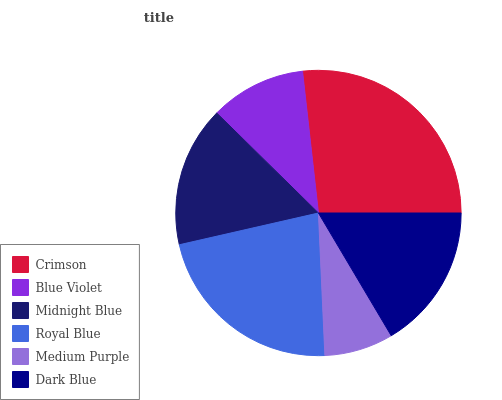Is Medium Purple the minimum?
Answer yes or no. Yes. Is Crimson the maximum?
Answer yes or no. Yes. Is Blue Violet the minimum?
Answer yes or no. No. Is Blue Violet the maximum?
Answer yes or no. No. Is Crimson greater than Blue Violet?
Answer yes or no. Yes. Is Blue Violet less than Crimson?
Answer yes or no. Yes. Is Blue Violet greater than Crimson?
Answer yes or no. No. Is Crimson less than Blue Violet?
Answer yes or no. No. Is Dark Blue the high median?
Answer yes or no. Yes. Is Midnight Blue the low median?
Answer yes or no. Yes. Is Crimson the high median?
Answer yes or no. No. Is Blue Violet the low median?
Answer yes or no. No. 